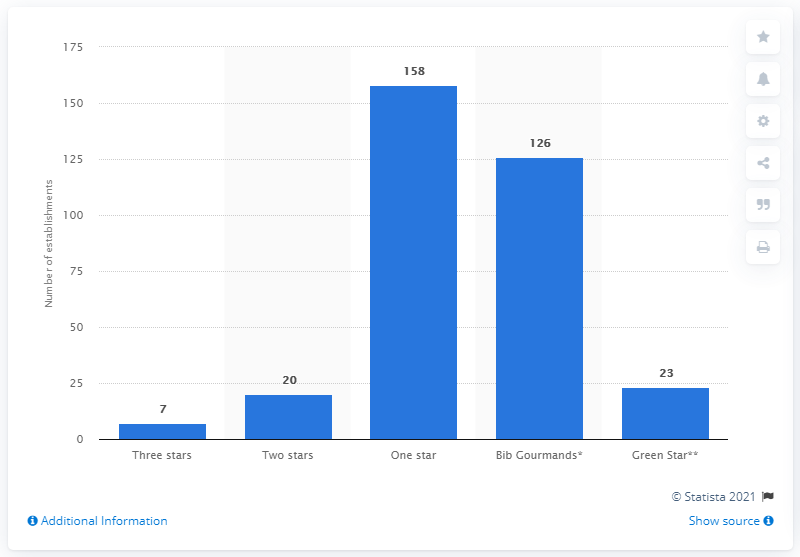Draw attention to some important aspects in this diagram. Out of the total number of restaurants awarded, 23 were given the prestigious 'Green Star' rating. There were 126 restaurants that were rated as "Bib Gourmands. 